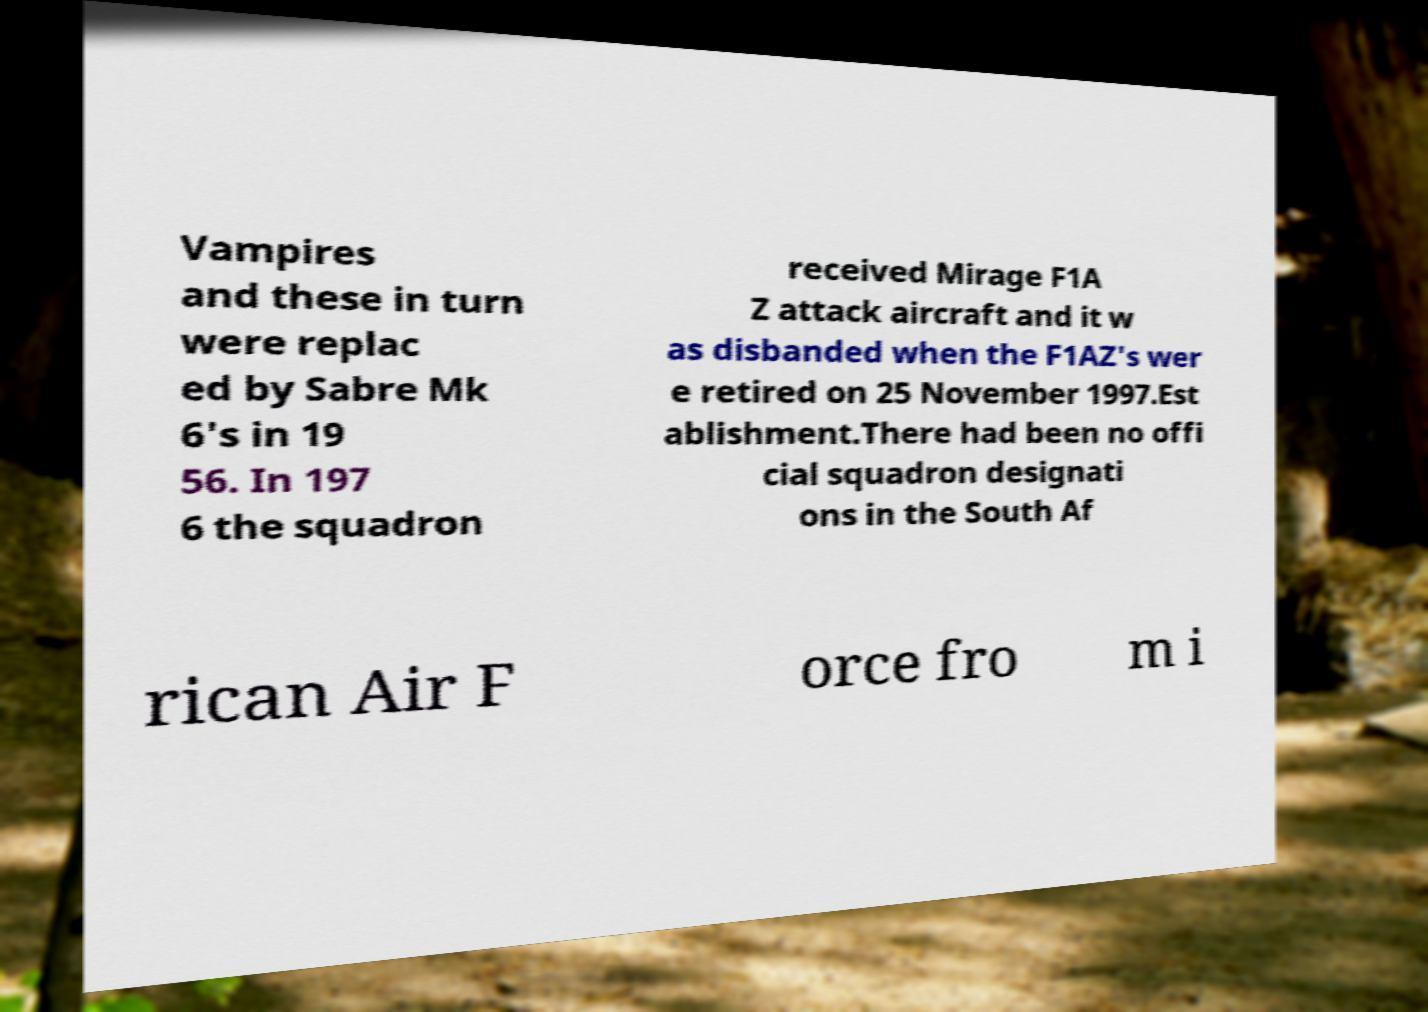Can you read and provide the text displayed in the image?This photo seems to have some interesting text. Can you extract and type it out for me? Vampires and these in turn were replac ed by Sabre Mk 6's in 19 56. In 197 6 the squadron received Mirage F1A Z attack aircraft and it w as disbanded when the F1AZ's wer e retired on 25 November 1997.Est ablishment.There had been no offi cial squadron designati ons in the South Af rican Air F orce fro m i 